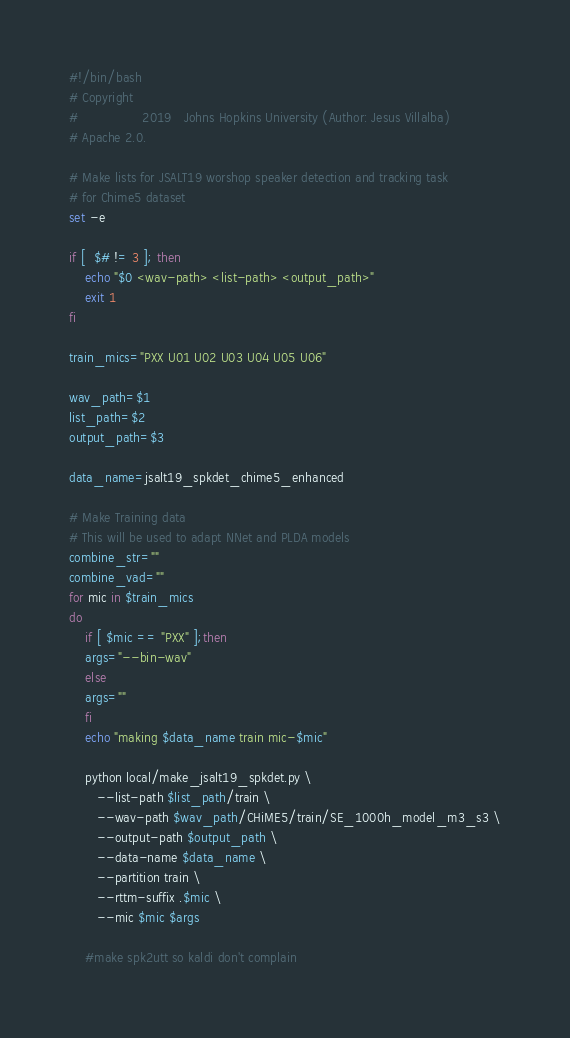Convert code to text. <code><loc_0><loc_0><loc_500><loc_500><_Bash_>#!/bin/bash
# Copyright
#                2019   Johns Hopkins University (Author: Jesus Villalba)
# Apache 2.0.

# Make lists for JSALT19 worshop speaker detection and tracking task
# for Chime5 dataset
set -e 

if [  $# != 3 ]; then
    echo "$0 <wav-path> <list-path> <output_path>"
    exit 1
fi

train_mics="PXX U01 U02 U03 U04 U05 U06"

wav_path=$1
list_path=$2
output_path=$3

data_name=jsalt19_spkdet_chime5_enhanced

# Make Training data
# This will be used to adapt NNet and PLDA models
combine_str=""
combine_vad=""
for mic in $train_mics
do
    if [ $mic == "PXX" ];then
	args="--bin-wav"
    else
	args=""
    fi
    echo "making $data_name train mic-$mic"

    python local/make_jsalt19_spkdet.py \
	   --list-path $list_path/train \
	   --wav-path $wav_path/CHiME5/train/SE_1000h_model_m3_s3 \
	   --output-path $output_path \
	   --data-name $data_name \
	   --partition train \
	   --rttm-suffix .$mic \
	   --mic $mic $args 

    #make spk2utt so kaldi don't complain</code> 